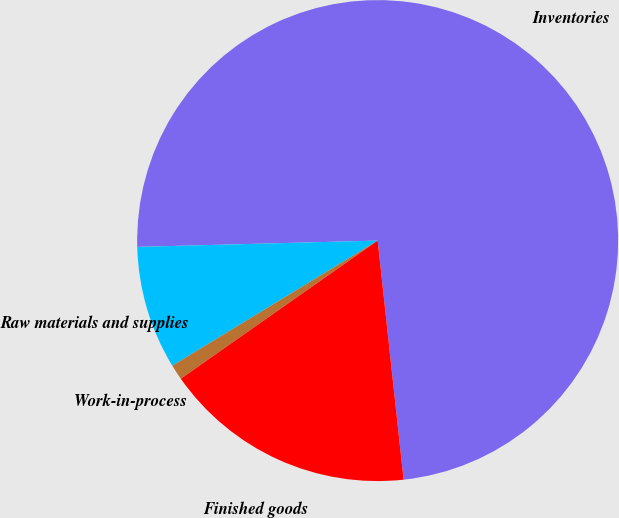Convert chart to OTSL. <chart><loc_0><loc_0><loc_500><loc_500><pie_chart><fcel>Inventories<fcel>Raw materials and supplies<fcel>Work-in-process<fcel>Finished goods<nl><fcel>73.7%<fcel>8.29%<fcel>1.03%<fcel>16.98%<nl></chart> 